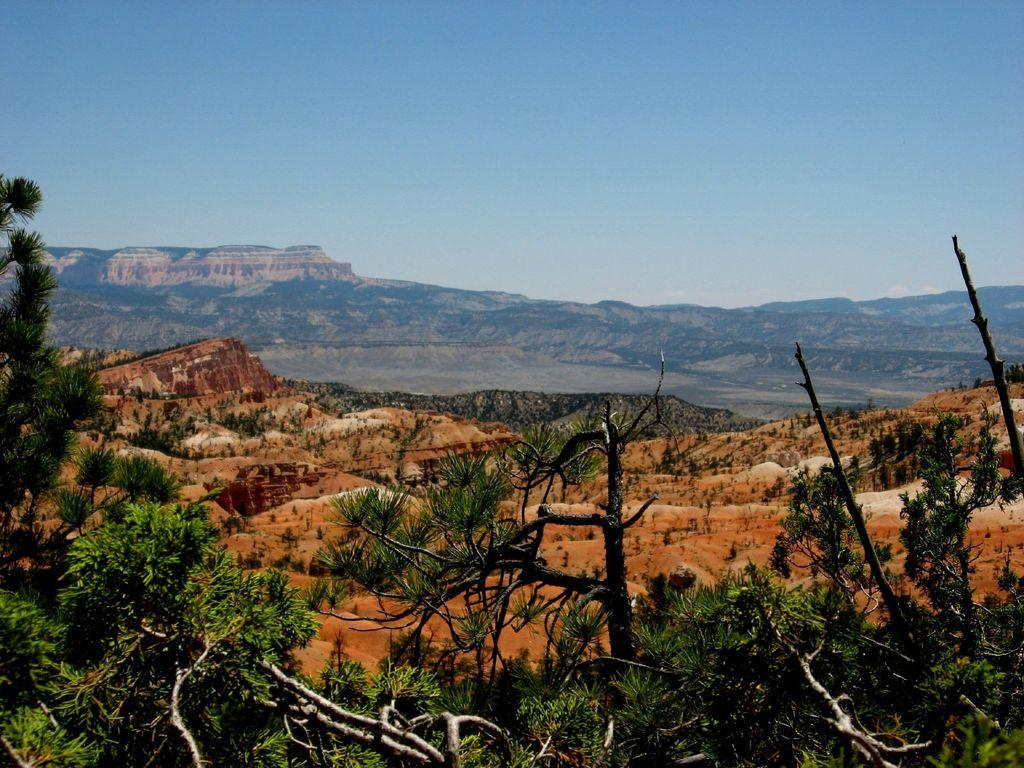What type of natural feature can be seen in the image? There is a tree in the image. What type of landscape is visible in the image? There are mountains in the image. What color is the sky in the image? The sky is blue in color. Can you hear the father's voice downtown in the image? There is no father or downtown location present in the image, and therefore no sound can be heard. 